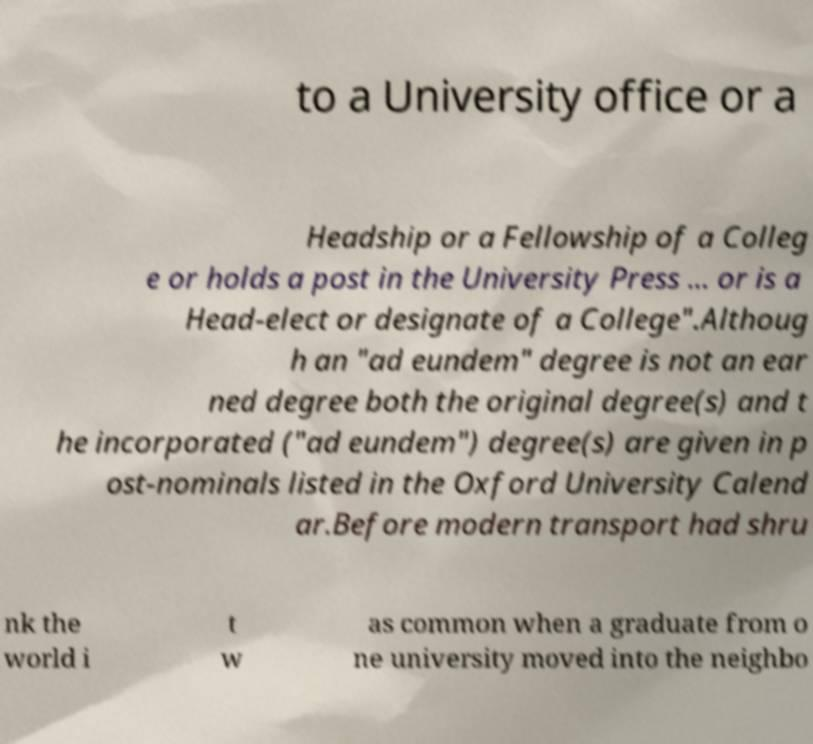Please identify and transcribe the text found in this image. to a University office or a Headship or a Fellowship of a Colleg e or holds a post in the University Press ... or is a Head-elect or designate of a College".Althoug h an "ad eundem" degree is not an ear ned degree both the original degree(s) and t he incorporated ("ad eundem") degree(s) are given in p ost-nominals listed in the Oxford University Calend ar.Before modern transport had shru nk the world i t w as common when a graduate from o ne university moved into the neighbo 